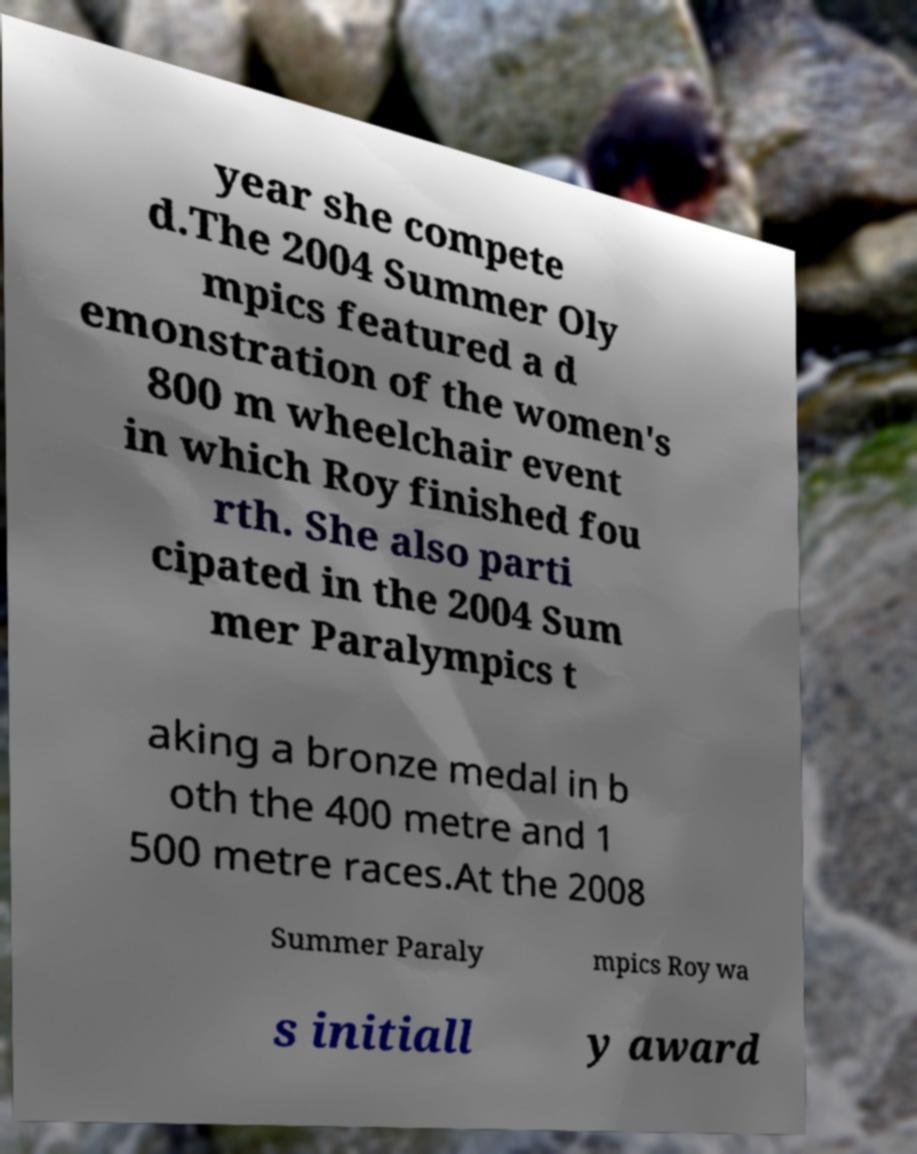Please read and relay the text visible in this image. What does it say? year she compete d.The 2004 Summer Oly mpics featured a d emonstration of the women's 800 m wheelchair event in which Roy finished fou rth. She also parti cipated in the 2004 Sum mer Paralympics t aking a bronze medal in b oth the 400 metre and 1 500 metre races.At the 2008 Summer Paraly mpics Roy wa s initiall y award 